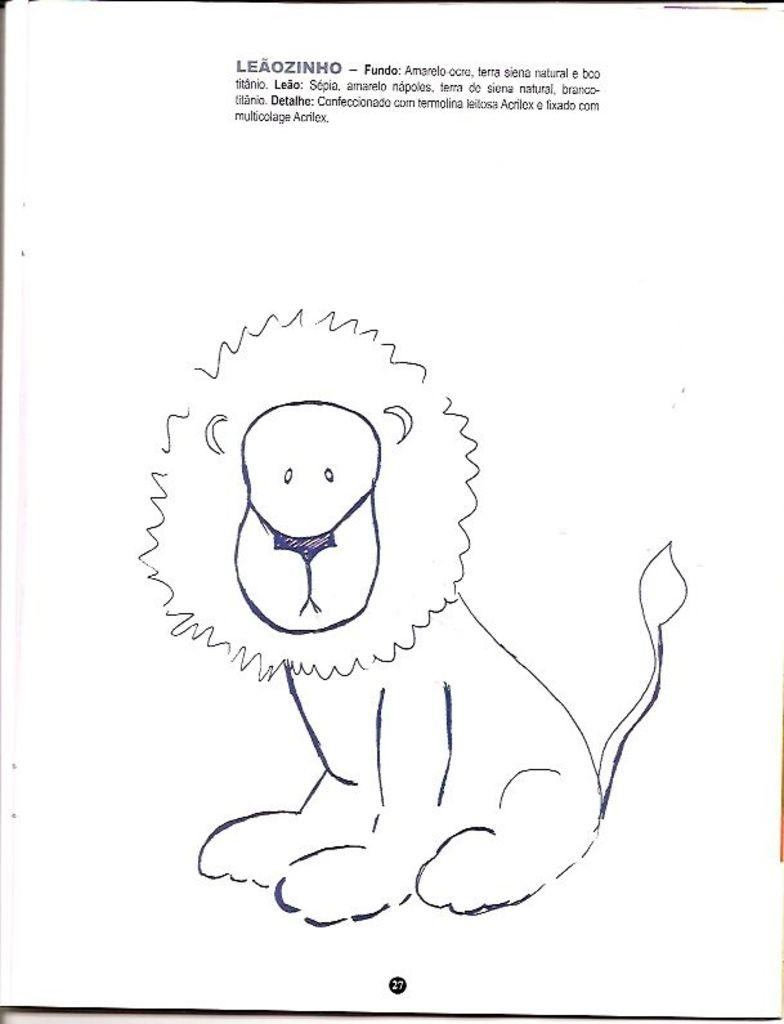What is depicted in the image? There is a drawing of an animal in the image. What else can be found in the image besides the drawing? There is text in the image. What type of rod is being used to rub the animal in the image? There is no rod or rubbing action depicted in the image; it features a drawing of an animal and text. 